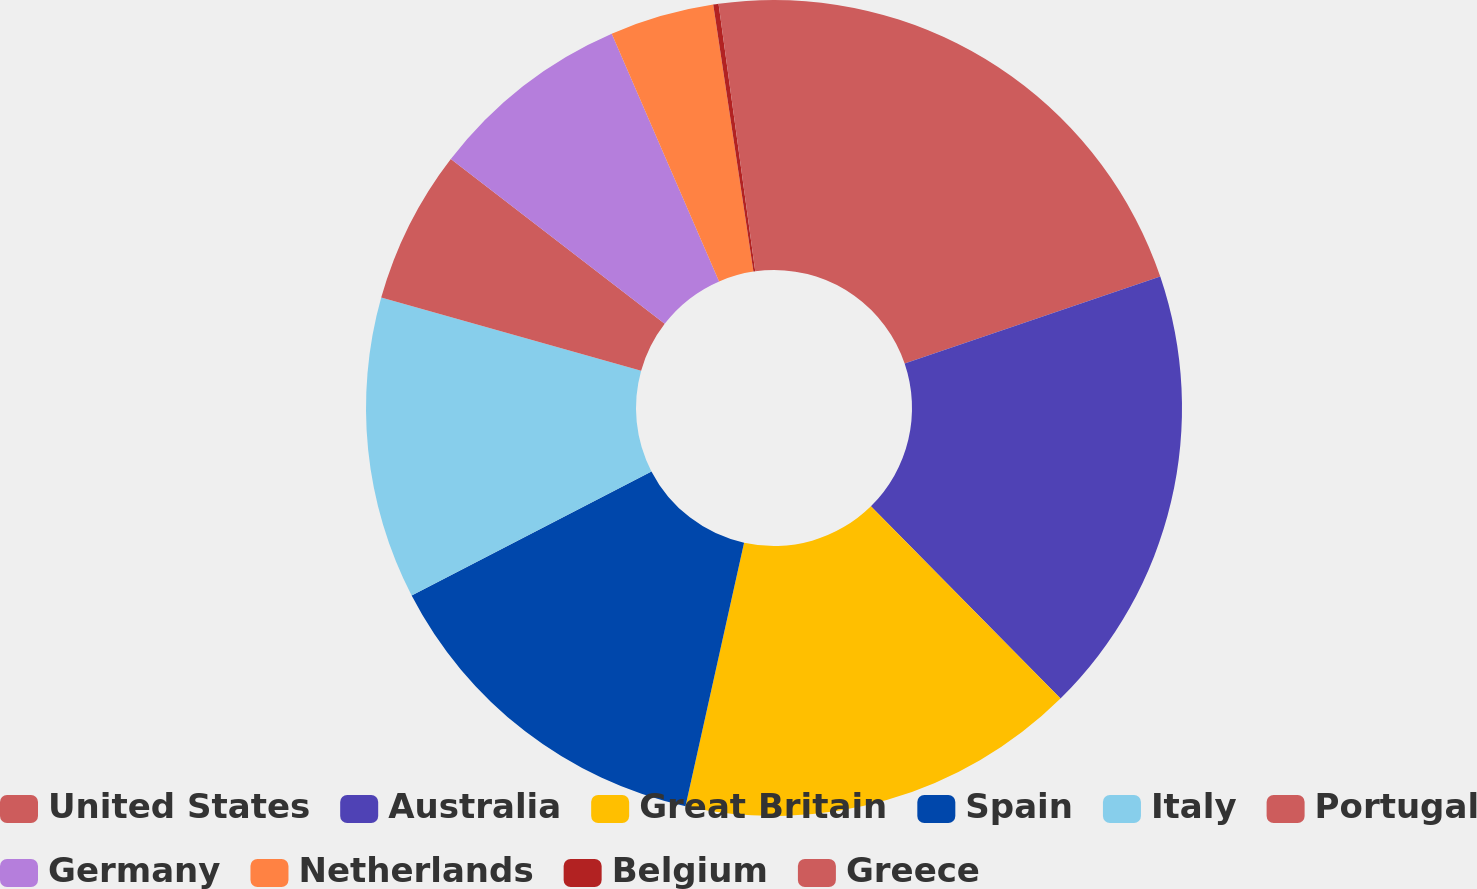<chart> <loc_0><loc_0><loc_500><loc_500><pie_chart><fcel>United States<fcel>Australia<fcel>Great Britain<fcel>Spain<fcel>Italy<fcel>Portugal<fcel>Germany<fcel>Netherlands<fcel>Belgium<fcel>Greece<nl><fcel>19.78%<fcel>17.83%<fcel>15.87%<fcel>13.92%<fcel>11.96%<fcel>6.09%<fcel>8.04%<fcel>4.13%<fcel>0.21%<fcel>2.17%<nl></chart> 